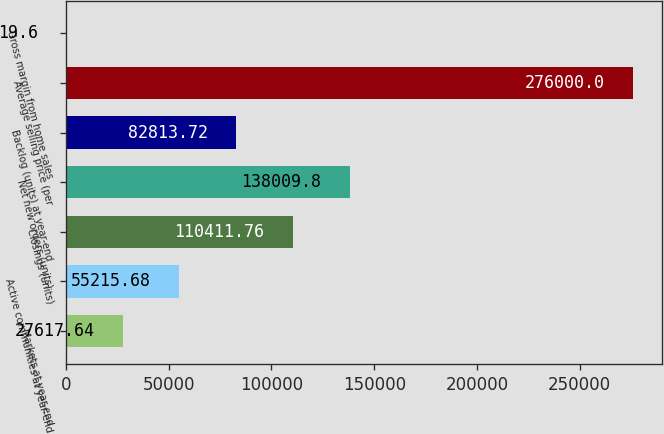Convert chart. <chart><loc_0><loc_0><loc_500><loc_500><bar_chart><fcel>Markets at year-end<fcel>Active communities at year-end<fcel>Closings (units)<fcel>Net new orders (units)<fcel>Backlog (units) at year-end<fcel>Average selling price (per<fcel>Gross margin from home sales<nl><fcel>27617.6<fcel>55215.7<fcel>110412<fcel>138010<fcel>82813.7<fcel>276000<fcel>19.6<nl></chart> 